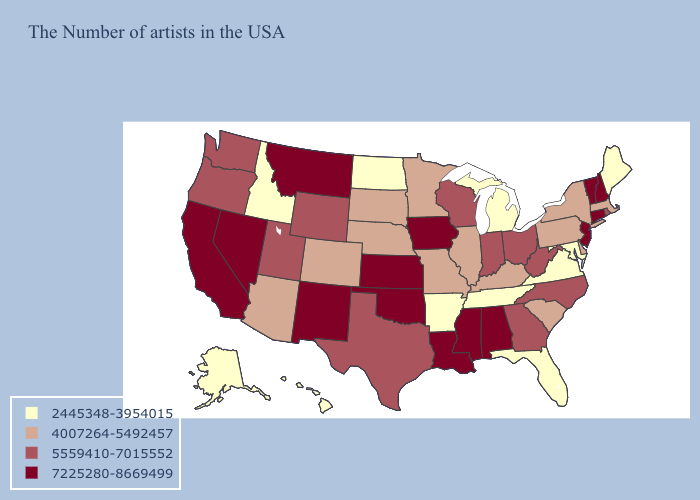Among the states that border Louisiana , does Texas have the lowest value?
Answer briefly. No. Name the states that have a value in the range 5559410-7015552?
Write a very short answer. Rhode Island, North Carolina, West Virginia, Ohio, Georgia, Indiana, Wisconsin, Texas, Wyoming, Utah, Washington, Oregon. Which states have the highest value in the USA?
Quick response, please. New Hampshire, Vermont, Connecticut, New Jersey, Alabama, Mississippi, Louisiana, Iowa, Kansas, Oklahoma, New Mexico, Montana, Nevada, California. Name the states that have a value in the range 4007264-5492457?
Write a very short answer. Massachusetts, New York, Delaware, Pennsylvania, South Carolina, Kentucky, Illinois, Missouri, Minnesota, Nebraska, South Dakota, Colorado, Arizona. Which states have the highest value in the USA?
Keep it brief. New Hampshire, Vermont, Connecticut, New Jersey, Alabama, Mississippi, Louisiana, Iowa, Kansas, Oklahoma, New Mexico, Montana, Nevada, California. Does Delaware have the lowest value in the USA?
Short answer required. No. Does Tennessee have the lowest value in the USA?
Write a very short answer. Yes. What is the value of Oregon?
Be succinct. 5559410-7015552. Name the states that have a value in the range 2445348-3954015?
Answer briefly. Maine, Maryland, Virginia, Florida, Michigan, Tennessee, Arkansas, North Dakota, Idaho, Alaska, Hawaii. What is the value of Connecticut?
Short answer required. 7225280-8669499. What is the value of Arkansas?
Be succinct. 2445348-3954015. Name the states that have a value in the range 5559410-7015552?
Write a very short answer. Rhode Island, North Carolina, West Virginia, Ohio, Georgia, Indiana, Wisconsin, Texas, Wyoming, Utah, Washington, Oregon. How many symbols are there in the legend?
Concise answer only. 4. Does the first symbol in the legend represent the smallest category?
Short answer required. Yes. 